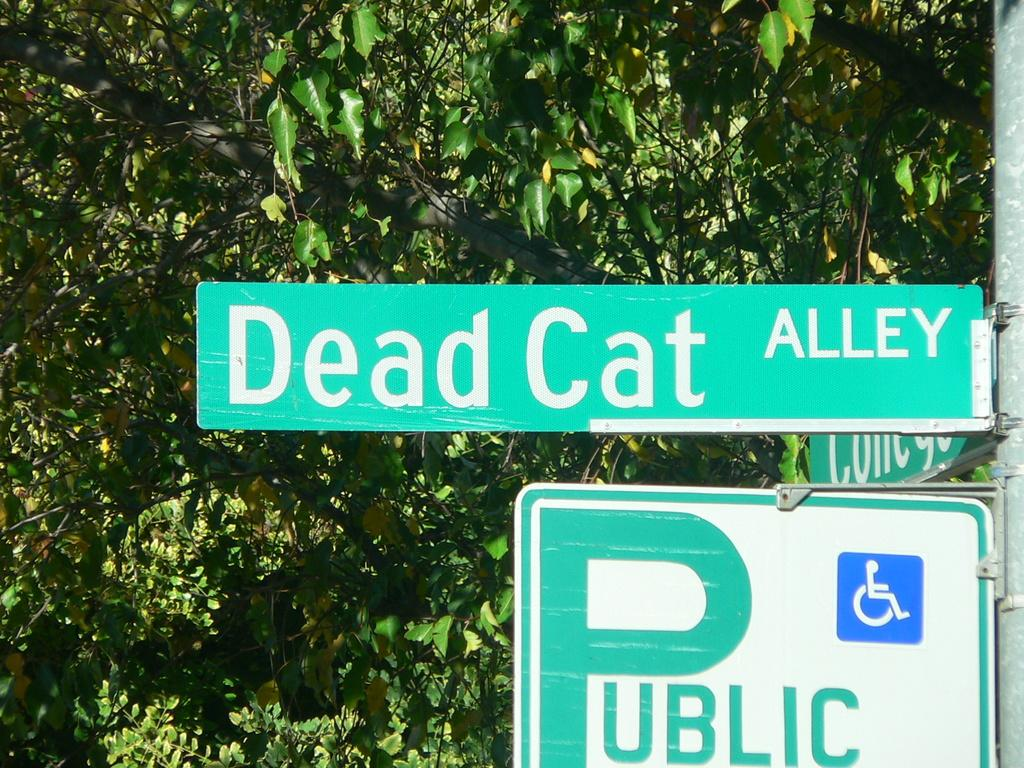Provide a one-sentence caption for the provided image. The name of the street is Dead Cat Alley. 